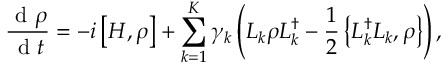Convert formula to latex. <formula><loc_0><loc_0><loc_500><loc_500>\frac { d \rho } { d t } = - i \left [ H , \rho \right ] + \sum _ { k = 1 } ^ { K } \gamma _ { k } \left ( L _ { k } \rho L _ { k } ^ { \dag } - \frac { 1 } { 2 } \left \{ L _ { k } ^ { \dag } L _ { k } , \rho \right \} \right ) ,</formula> 